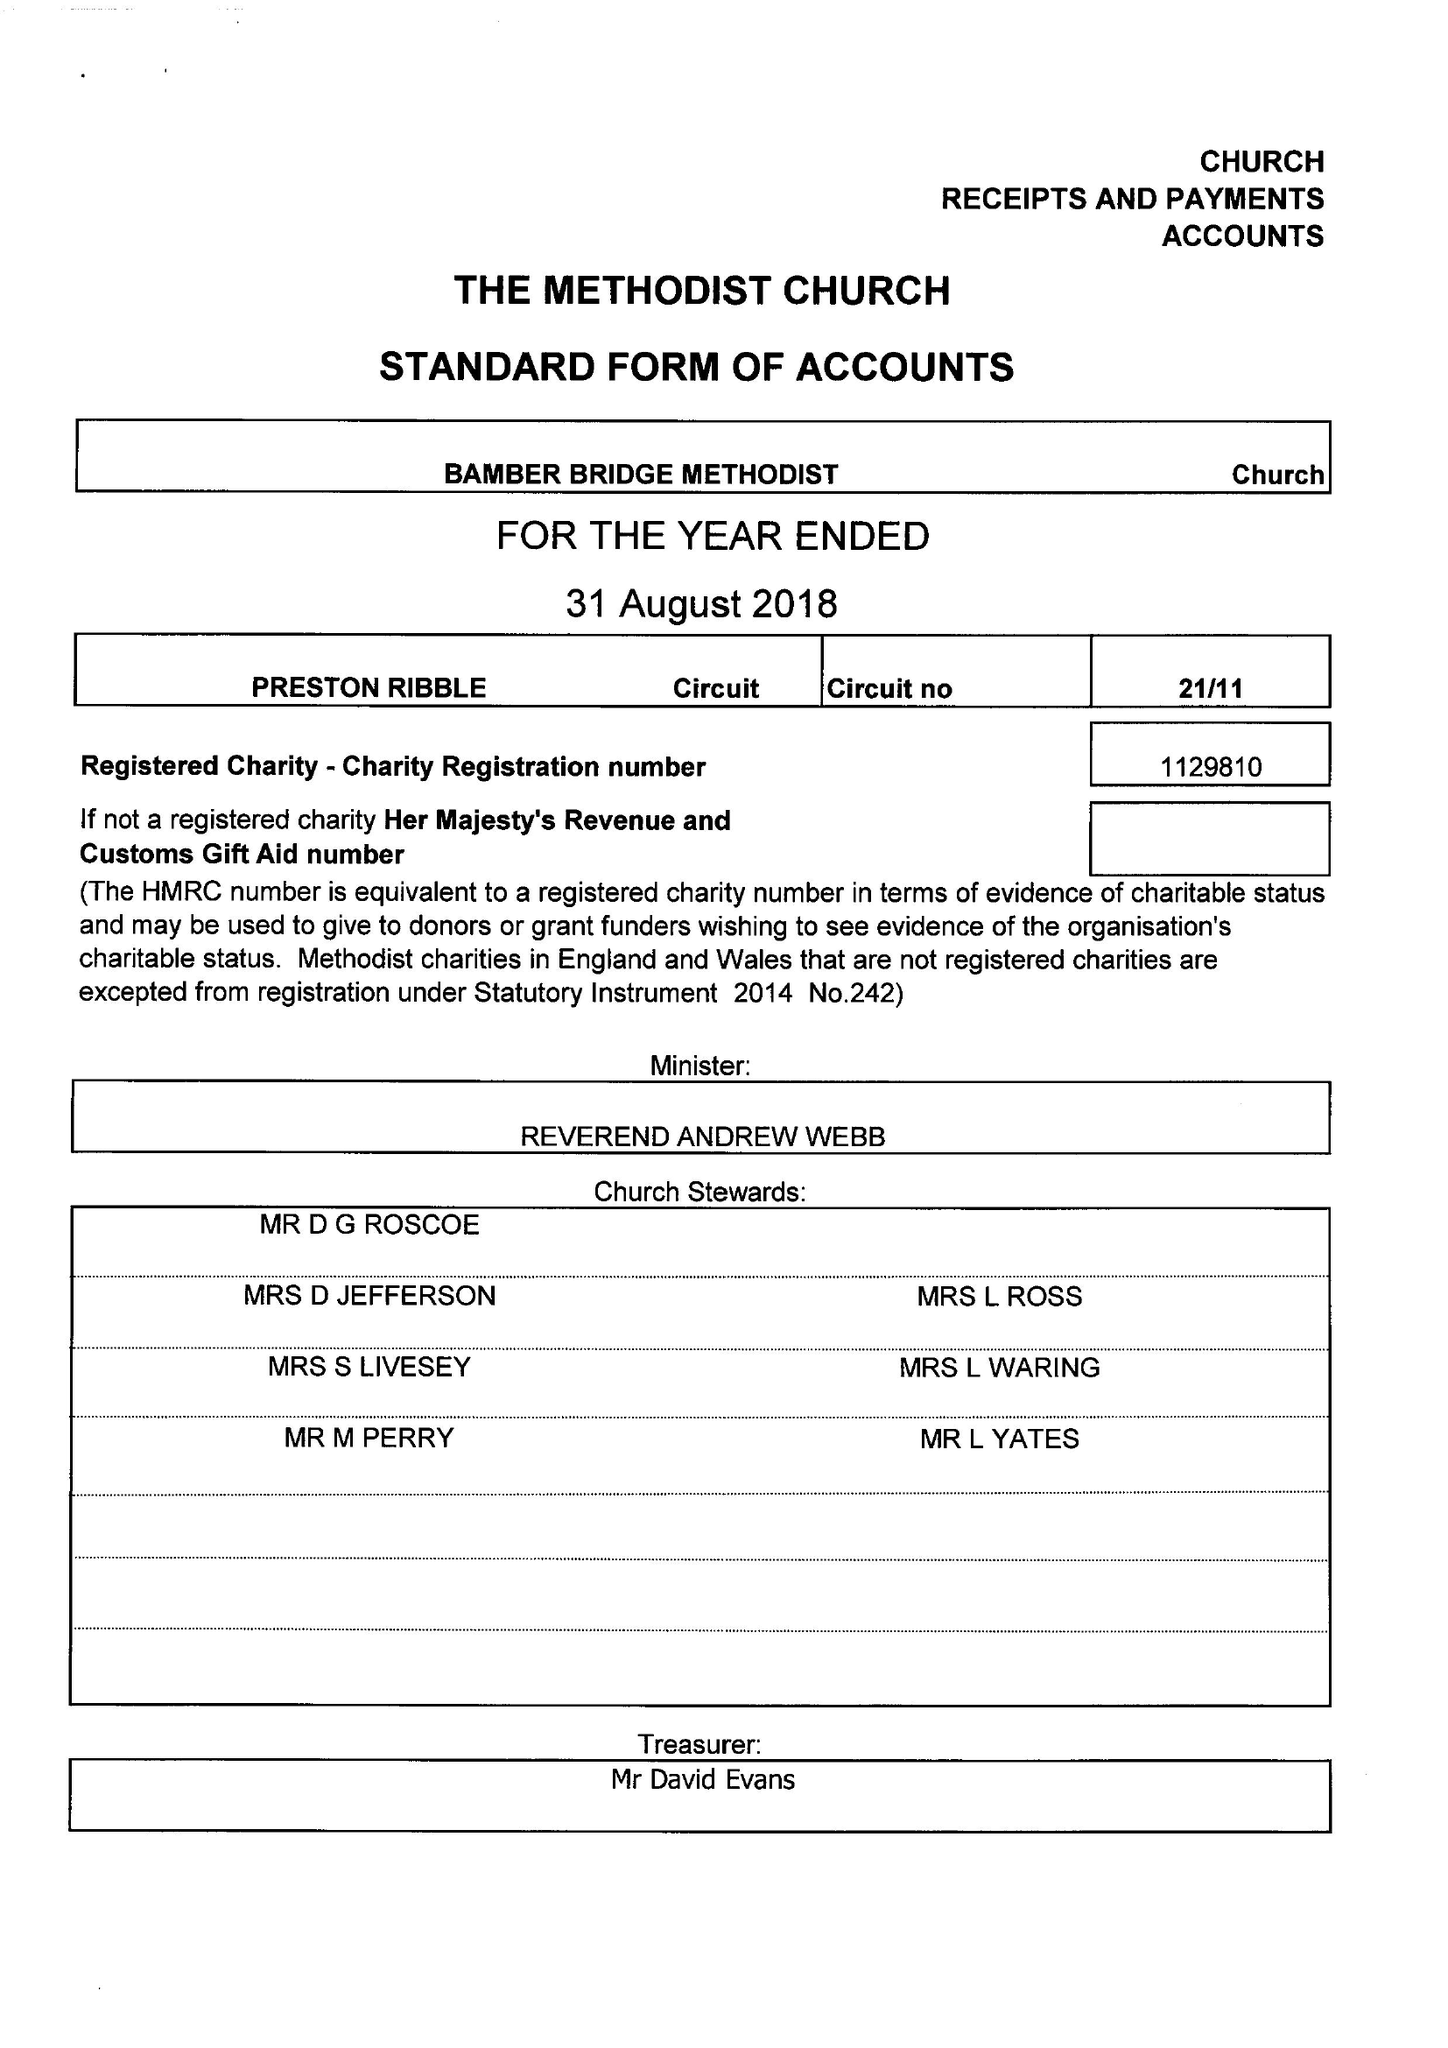What is the value for the income_annually_in_british_pounds?
Answer the question using a single word or phrase. 65907.00 